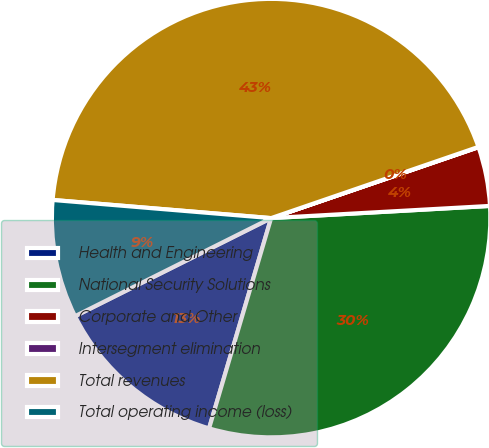Convert chart to OTSL. <chart><loc_0><loc_0><loc_500><loc_500><pie_chart><fcel>Health and Engineering<fcel>National Security Solutions<fcel>Corporate and Other<fcel>Intersegment elimination<fcel>Total revenues<fcel>Total operating income (loss)<nl><fcel>13.05%<fcel>30.45%<fcel>4.36%<fcel>0.02%<fcel>43.41%<fcel>8.7%<nl></chart> 